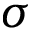<formula> <loc_0><loc_0><loc_500><loc_500>\sigma</formula> 